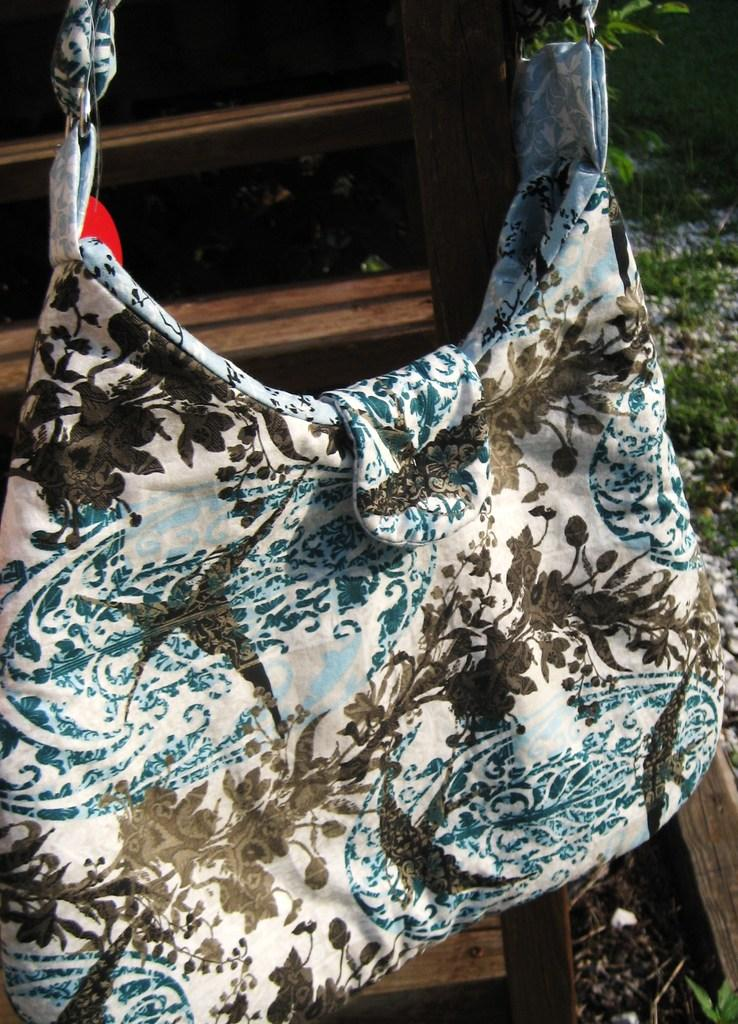What type of item is visible in the image? There is a handbag in the image. What color is the handbag? The handbag is white in color. What flavor of dust can be seen on the handbag in the image? There is no dust present on the handbag in the image, and therefore no flavor can be determined. 